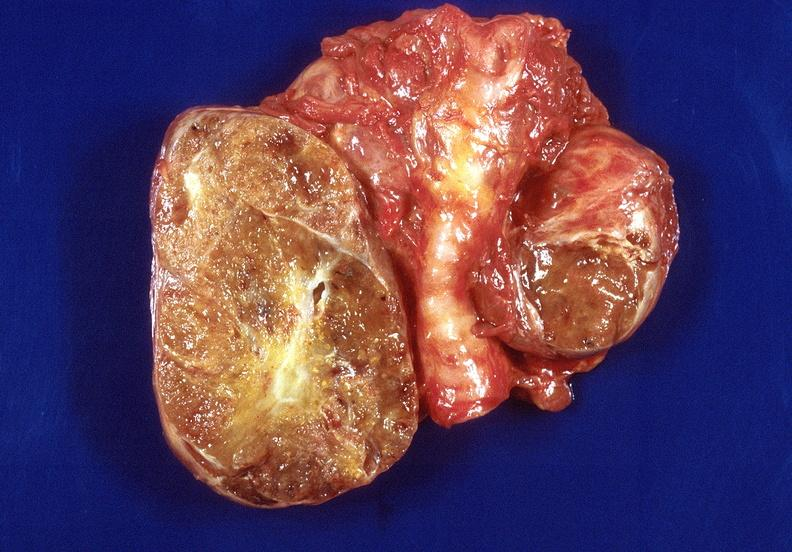does this image show thyroid, goiter?
Answer the question using a single word or phrase. Yes 